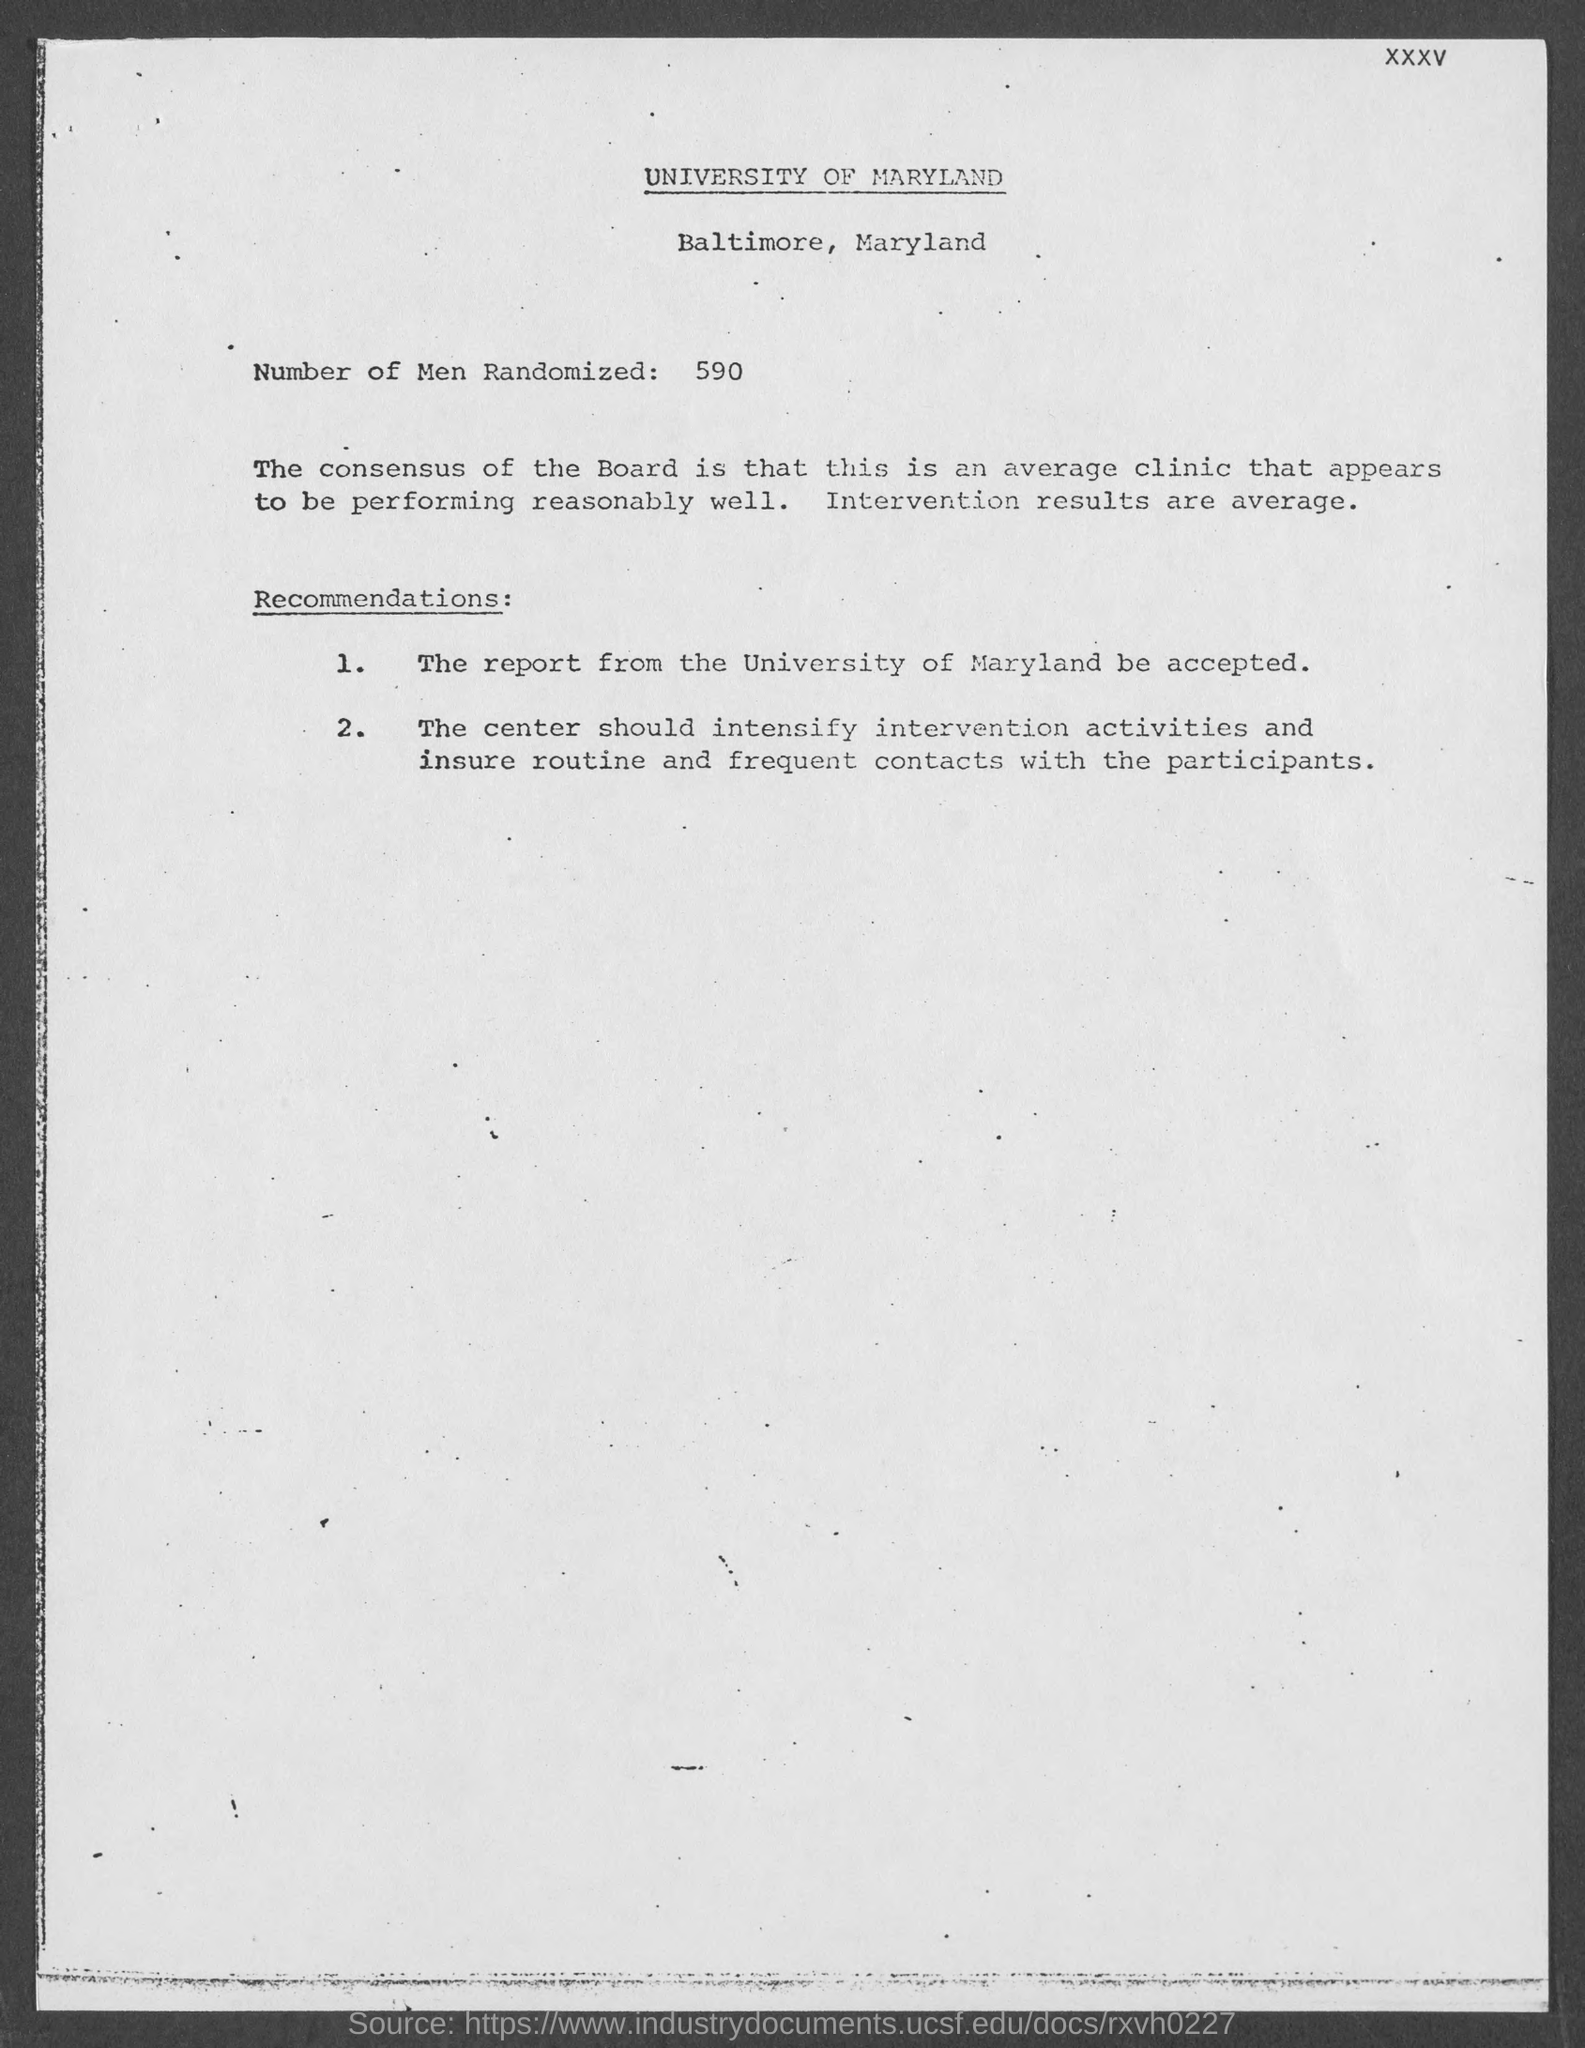List a handful of essential elements in this visual. The University of Maryland is mentioned in this document. A total of 590 men were randomly selected for the study. The University of Maryland is situated in Baltimore, Maryland. 